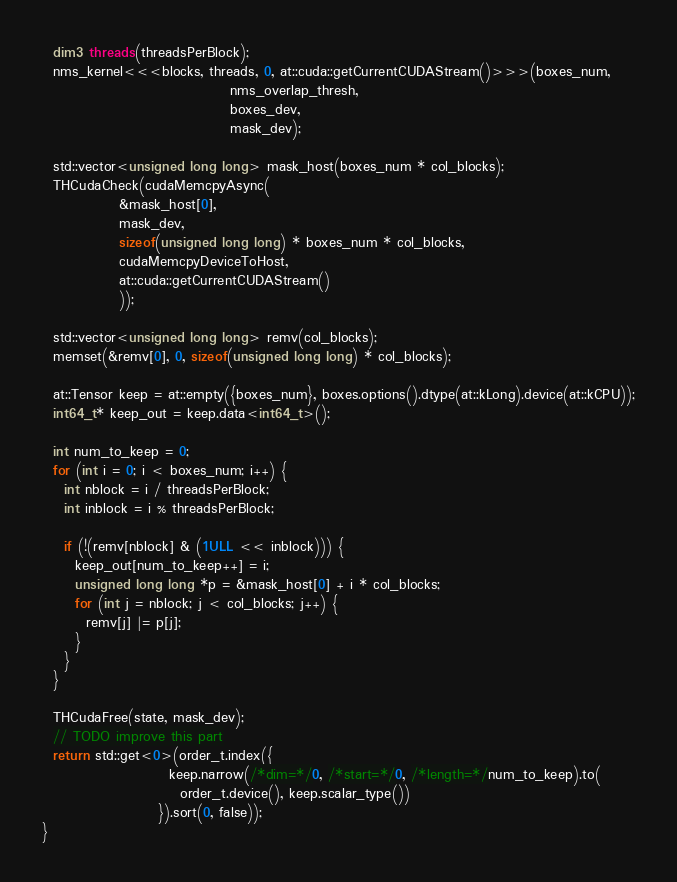Convert code to text. <code><loc_0><loc_0><loc_500><loc_500><_Cuda_>  dim3 threads(threadsPerBlock);
  nms_kernel<<<blocks, threads, 0, at::cuda::getCurrentCUDAStream()>>>(boxes_num,
                                  nms_overlap_thresh,
                                  boxes_dev,
                                  mask_dev);

  std::vector<unsigned long long> mask_host(boxes_num * col_blocks);
  THCudaCheck(cudaMemcpyAsync(
			  &mask_host[0],
			  mask_dev,
			  sizeof(unsigned long long) * boxes_num * col_blocks,
			  cudaMemcpyDeviceToHost,
			  at::cuda::getCurrentCUDAStream()
			  ));

  std::vector<unsigned long long> remv(col_blocks);
  memset(&remv[0], 0, sizeof(unsigned long long) * col_blocks);

  at::Tensor keep = at::empty({boxes_num}, boxes.options().dtype(at::kLong).device(at::kCPU));
  int64_t* keep_out = keep.data<int64_t>();

  int num_to_keep = 0;
  for (int i = 0; i < boxes_num; i++) {
    int nblock = i / threadsPerBlock;
    int inblock = i % threadsPerBlock;

    if (!(remv[nblock] & (1ULL << inblock))) {
      keep_out[num_to_keep++] = i;
      unsigned long long *p = &mask_host[0] + i * col_blocks;
      for (int j = nblock; j < col_blocks; j++) {
        remv[j] |= p[j];
      }
    }
  }

  THCudaFree(state, mask_dev);
  // TODO improve this part
  return std::get<0>(order_t.index({
                       keep.narrow(/*dim=*/0, /*start=*/0, /*length=*/num_to_keep).to(
                         order_t.device(), keep.scalar_type())
                     }).sort(0, false));
}
</code> 